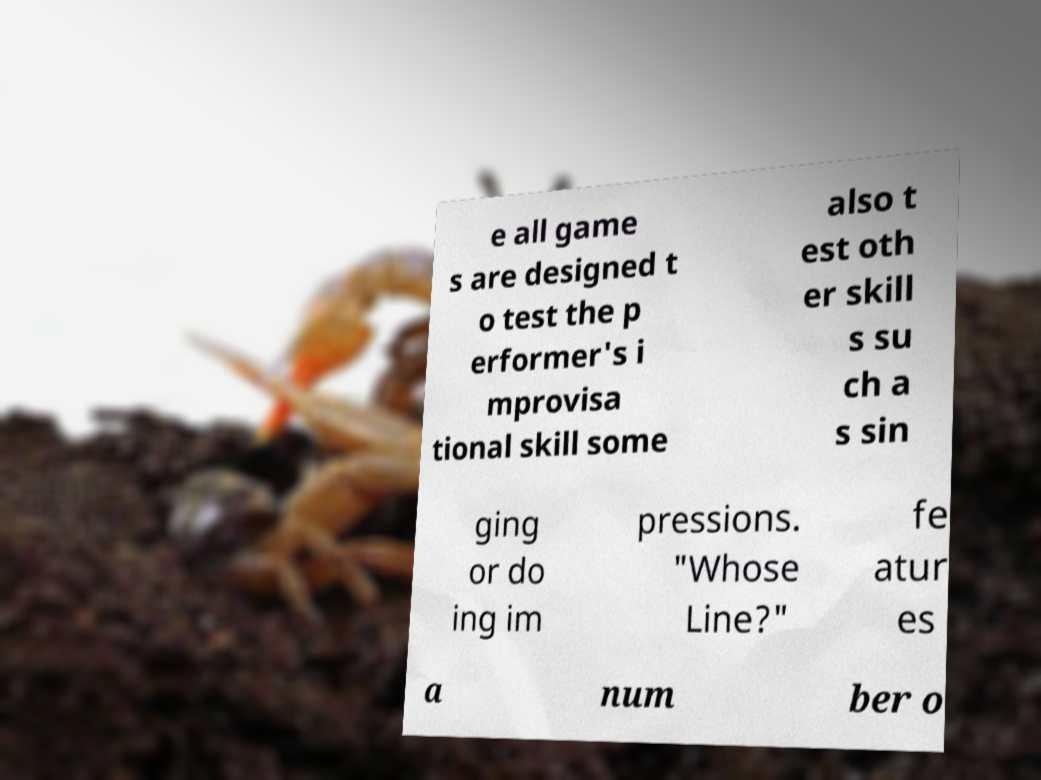For documentation purposes, I need the text within this image transcribed. Could you provide that? e all game s are designed t o test the p erformer's i mprovisa tional skill some also t est oth er skill s su ch a s sin ging or do ing im pressions. "Whose Line?" fe atur es a num ber o 